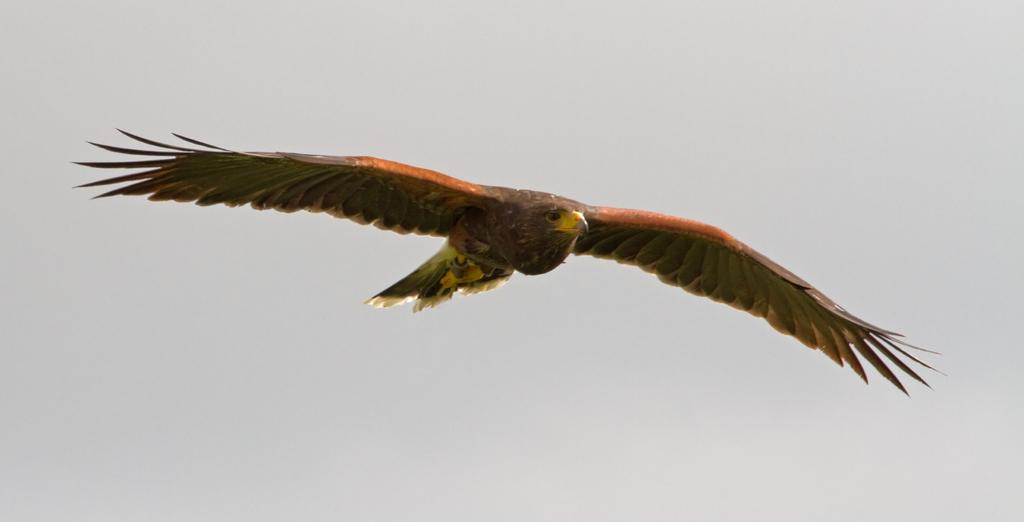What animal is featured in the image? There is an eagle in the image. What is the eagle doing in the image? The eagle is flying in the air. What can be seen in the background of the image? The sky is visible in the background of the image. What is the color of the sky in the image? The color of the sky is pale blue. What type of spoon is being used to stir the sticks in the image? There is no spoon or sticks present in the image; it features an eagle flying in the sky. What drug is the eagle taking in the image? There is no drug present in the image; it features an eagle flying in the sky. 